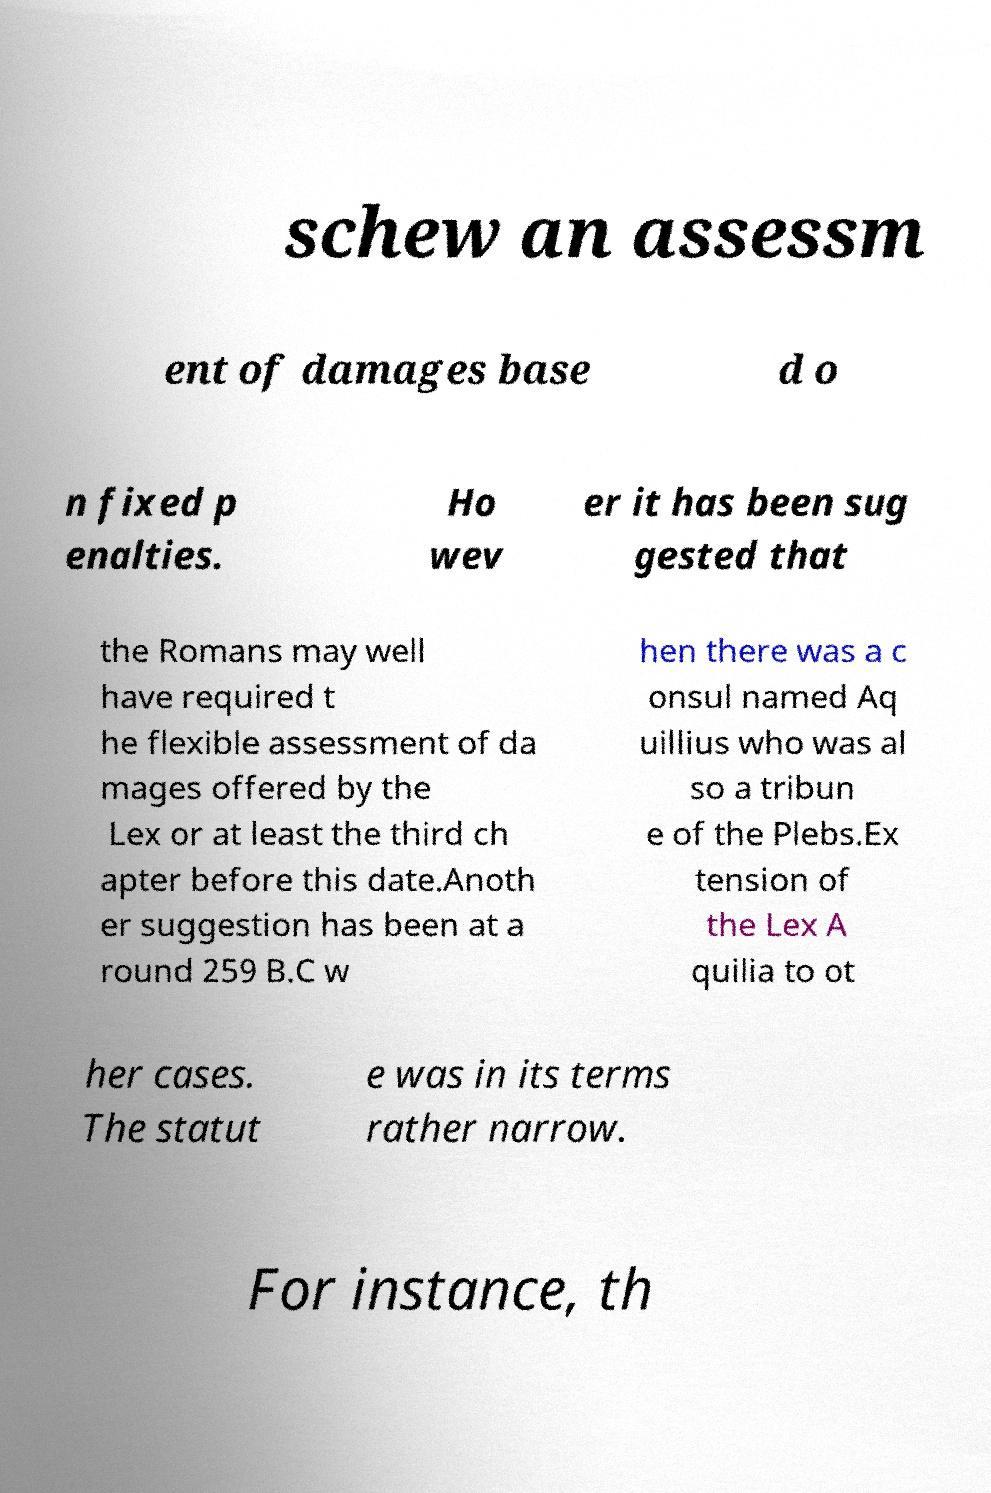Please identify and transcribe the text found in this image. schew an assessm ent of damages base d o n fixed p enalties. Ho wev er it has been sug gested that the Romans may well have required t he flexible assessment of da mages offered by the Lex or at least the third ch apter before this date.Anoth er suggestion has been at a round 259 B.C w hen there was a c onsul named Aq uillius who was al so a tribun e of the Plebs.Ex tension of the Lex A quilia to ot her cases. The statut e was in its terms rather narrow. For instance, th 